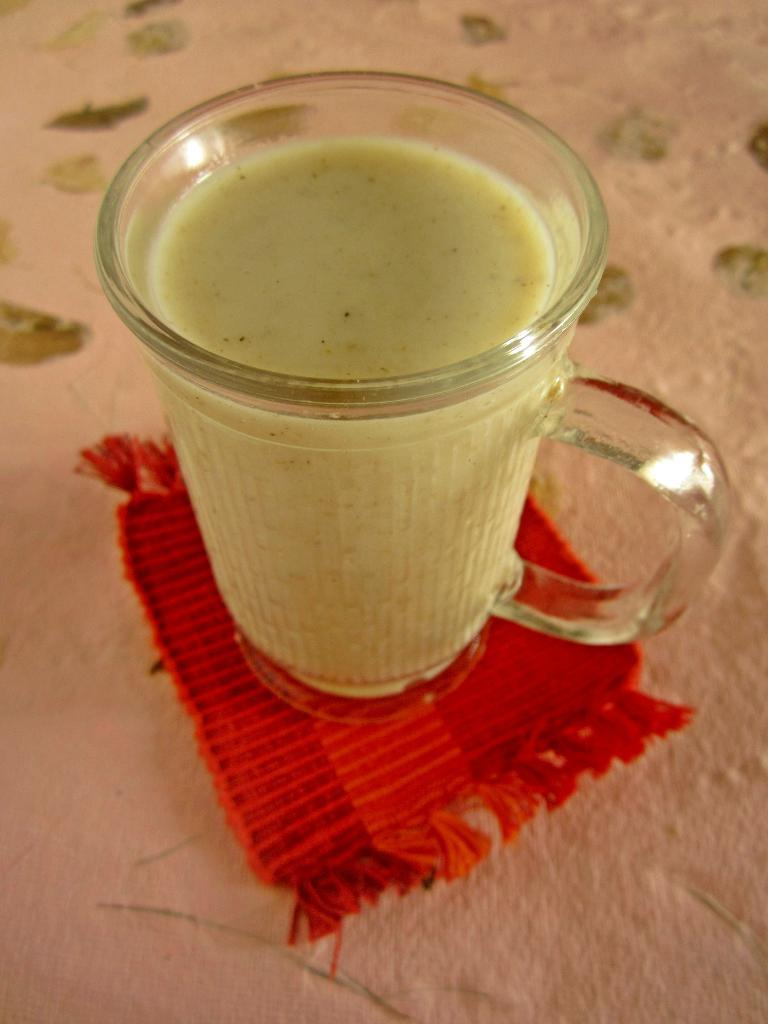What is in the glass that is visible in the image? The glass is filled with a drink. What is the color of the cloth on which the glass is placed? The cloth is red. How many knots are tied in the kite that is flying in the image? There is no kite present in the image, so it is not possible to determine how many knots are tied in it. 